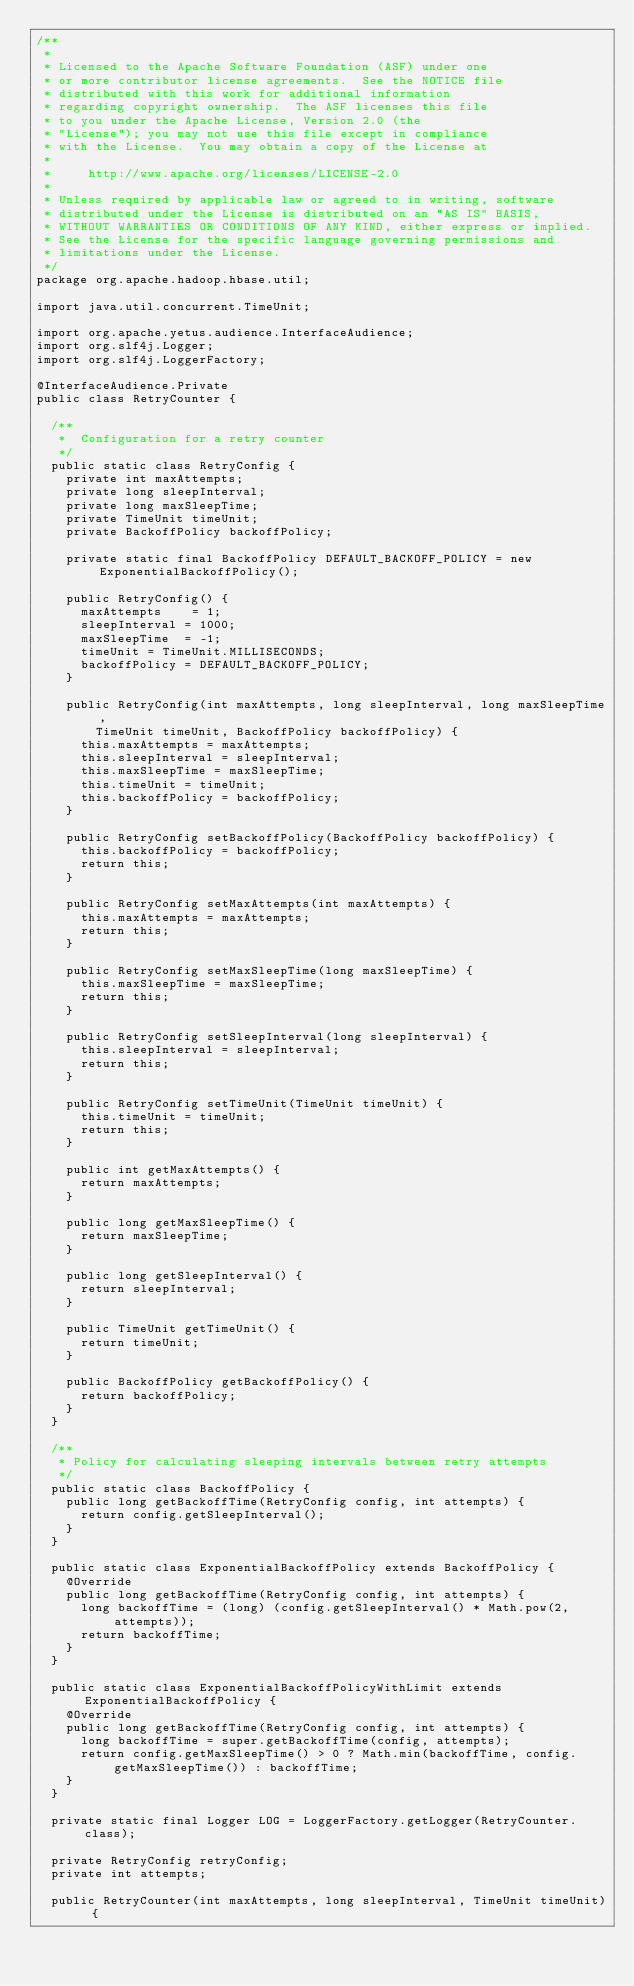<code> <loc_0><loc_0><loc_500><loc_500><_Java_>/**
 *
 * Licensed to the Apache Software Foundation (ASF) under one
 * or more contributor license agreements.  See the NOTICE file
 * distributed with this work for additional information
 * regarding copyright ownership.  The ASF licenses this file
 * to you under the Apache License, Version 2.0 (the
 * "License"); you may not use this file except in compliance
 * with the License.  You may obtain a copy of the License at
 *
 *     http://www.apache.org/licenses/LICENSE-2.0
 *
 * Unless required by applicable law or agreed to in writing, software
 * distributed under the License is distributed on an "AS IS" BASIS,
 * WITHOUT WARRANTIES OR CONDITIONS OF ANY KIND, either express or implied.
 * See the License for the specific language governing permissions and
 * limitations under the License.
 */
package org.apache.hadoop.hbase.util;

import java.util.concurrent.TimeUnit;

import org.apache.yetus.audience.InterfaceAudience;
import org.slf4j.Logger;
import org.slf4j.LoggerFactory;

@InterfaceAudience.Private
public class RetryCounter {

  /**
   *  Configuration for a retry counter
   */
  public static class RetryConfig {
    private int maxAttempts;
    private long sleepInterval;
    private long maxSleepTime;
    private TimeUnit timeUnit;
    private BackoffPolicy backoffPolicy;

    private static final BackoffPolicy DEFAULT_BACKOFF_POLICY = new ExponentialBackoffPolicy();

    public RetryConfig() {
      maxAttempts    = 1;
      sleepInterval = 1000;
      maxSleepTime  = -1;
      timeUnit = TimeUnit.MILLISECONDS;
      backoffPolicy = DEFAULT_BACKOFF_POLICY;
    }

    public RetryConfig(int maxAttempts, long sleepInterval, long maxSleepTime,
        TimeUnit timeUnit, BackoffPolicy backoffPolicy) {
      this.maxAttempts = maxAttempts;
      this.sleepInterval = sleepInterval;
      this.maxSleepTime = maxSleepTime;
      this.timeUnit = timeUnit;
      this.backoffPolicy = backoffPolicy;
    }

    public RetryConfig setBackoffPolicy(BackoffPolicy backoffPolicy) {
      this.backoffPolicy = backoffPolicy;
      return this;
    }

    public RetryConfig setMaxAttempts(int maxAttempts) {
      this.maxAttempts = maxAttempts;
      return this;
    }

    public RetryConfig setMaxSleepTime(long maxSleepTime) {
      this.maxSleepTime = maxSleepTime;
      return this;
    }

    public RetryConfig setSleepInterval(long sleepInterval) {
      this.sleepInterval = sleepInterval;
      return this;
    }

    public RetryConfig setTimeUnit(TimeUnit timeUnit) {
      this.timeUnit = timeUnit;
      return this;
    }

    public int getMaxAttempts() {
      return maxAttempts;
    }

    public long getMaxSleepTime() {
      return maxSleepTime;
    }

    public long getSleepInterval() {
      return sleepInterval;
    }

    public TimeUnit getTimeUnit() {
      return timeUnit;
    }

    public BackoffPolicy getBackoffPolicy() {
      return backoffPolicy;
    }
  }

  /**
   * Policy for calculating sleeping intervals between retry attempts
   */
  public static class BackoffPolicy {
    public long getBackoffTime(RetryConfig config, int attempts) {
      return config.getSleepInterval();
    }
  }

  public static class ExponentialBackoffPolicy extends BackoffPolicy {
    @Override
    public long getBackoffTime(RetryConfig config, int attempts) {
      long backoffTime = (long) (config.getSleepInterval() * Math.pow(2, attempts));
      return backoffTime;
    }
  }

  public static class ExponentialBackoffPolicyWithLimit extends ExponentialBackoffPolicy {
    @Override
    public long getBackoffTime(RetryConfig config, int attempts) {
      long backoffTime = super.getBackoffTime(config, attempts);
      return config.getMaxSleepTime() > 0 ? Math.min(backoffTime, config.getMaxSleepTime()) : backoffTime;
    }
  }

  private static final Logger LOG = LoggerFactory.getLogger(RetryCounter.class);

  private RetryConfig retryConfig;
  private int attempts;

  public RetryCounter(int maxAttempts, long sleepInterval, TimeUnit timeUnit) {</code> 